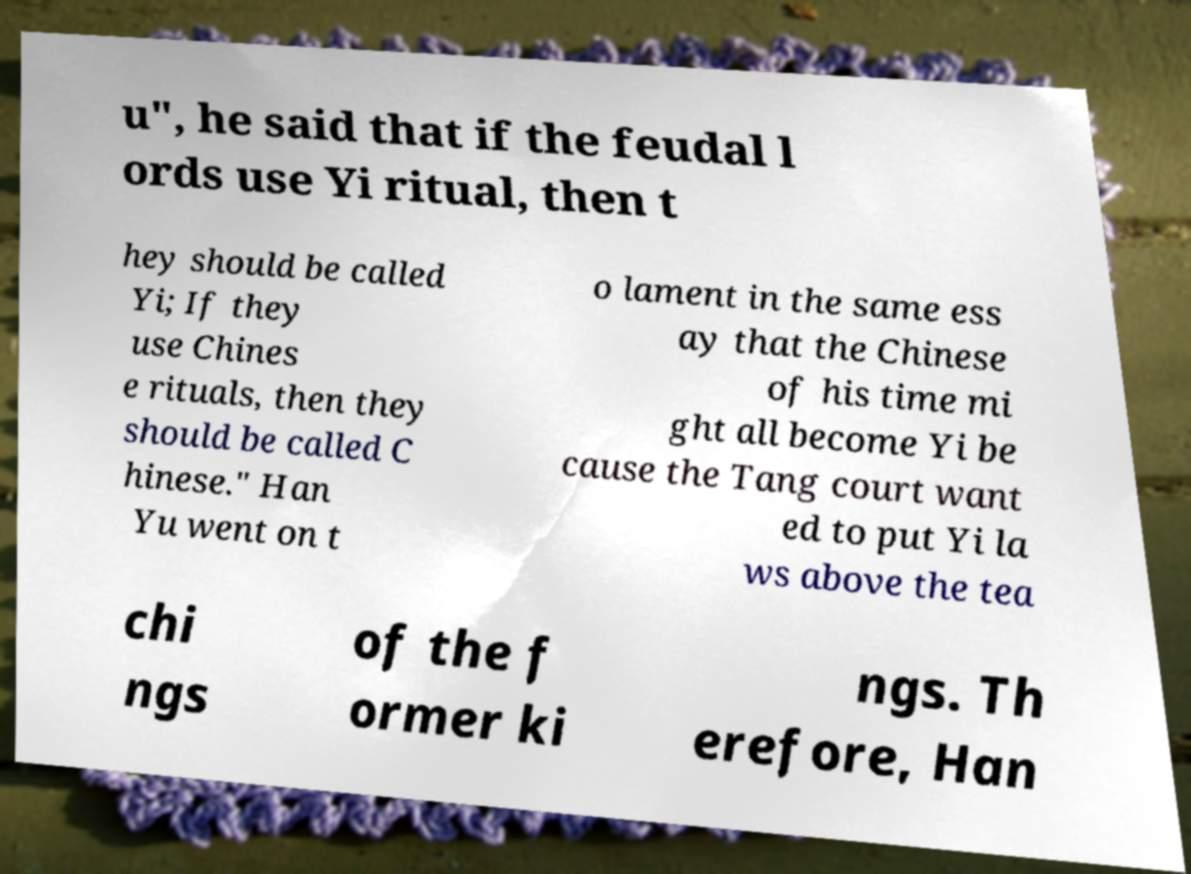Please read and relay the text visible in this image. What does it say? u", he said that if the feudal l ords use Yi ritual, then t hey should be called Yi; If they use Chines e rituals, then they should be called C hinese." Han Yu went on t o lament in the same ess ay that the Chinese of his time mi ght all become Yi be cause the Tang court want ed to put Yi la ws above the tea chi ngs of the f ormer ki ngs. Th erefore, Han 